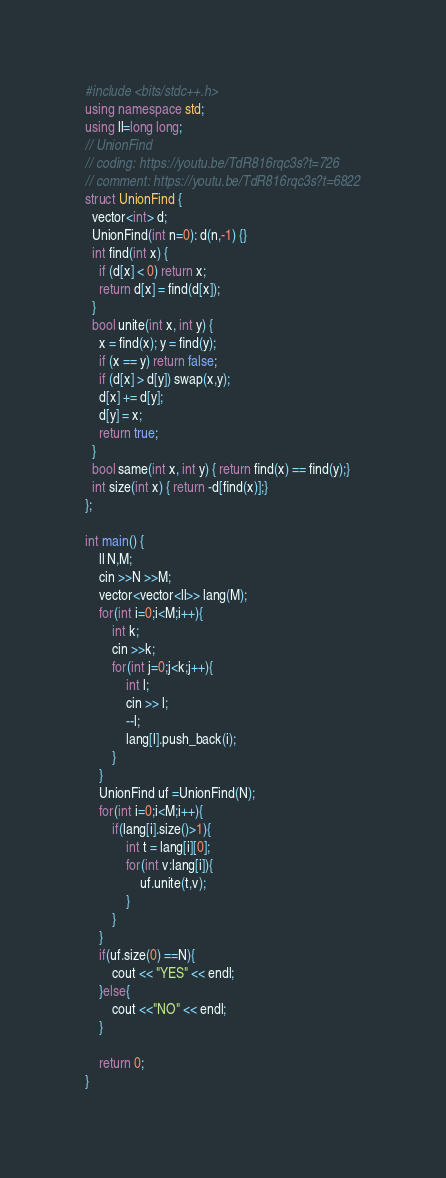Convert code to text. <code><loc_0><loc_0><loc_500><loc_500><_C++_>#include <bits/stdc++.h>
using namespace std;
using ll=long long;
// UnionFind
// coding: https://youtu.be/TdR816rqc3s?t=726
// comment: https://youtu.be/TdR816rqc3s?t=6822
struct UnionFind {
  vector<int> d;
  UnionFind(int n=0): d(n,-1) {}
  int find(int x) {
    if (d[x] < 0) return x;
    return d[x] = find(d[x]);
  }
  bool unite(int x, int y) {
    x = find(x); y = find(y);
    if (x == y) return false;
    if (d[x] > d[y]) swap(x,y);
    d[x] += d[y];
    d[y] = x;
    return true;
  }
  bool same(int x, int y) { return find(x) == find(y);}
  int size(int x) { return -d[find(x)];}
};

int main() {
    ll N,M;
    cin >>N >>M;
    vector<vector<ll>> lang(M);
    for(int i=0;i<M;i++){
        int k;
        cin >>k;
        for(int j=0;j<k;j++){
            int l;
            cin >> l;
            --l;
            lang[l].push_back(i);
        }
    }
    UnionFind uf =UnionFind(N);
    for(int i=0;i<M;i++){
        if(lang[i].size()>1){
            int t = lang[i][0];
            for(int v:lang[i]){
                uf.unite(t,v);
            }
        }
    }
    if(uf.size(0) ==N){
        cout << "YES" << endl;
    }else{
        cout <<"NO" << endl;
    }

    return 0;
}</code> 